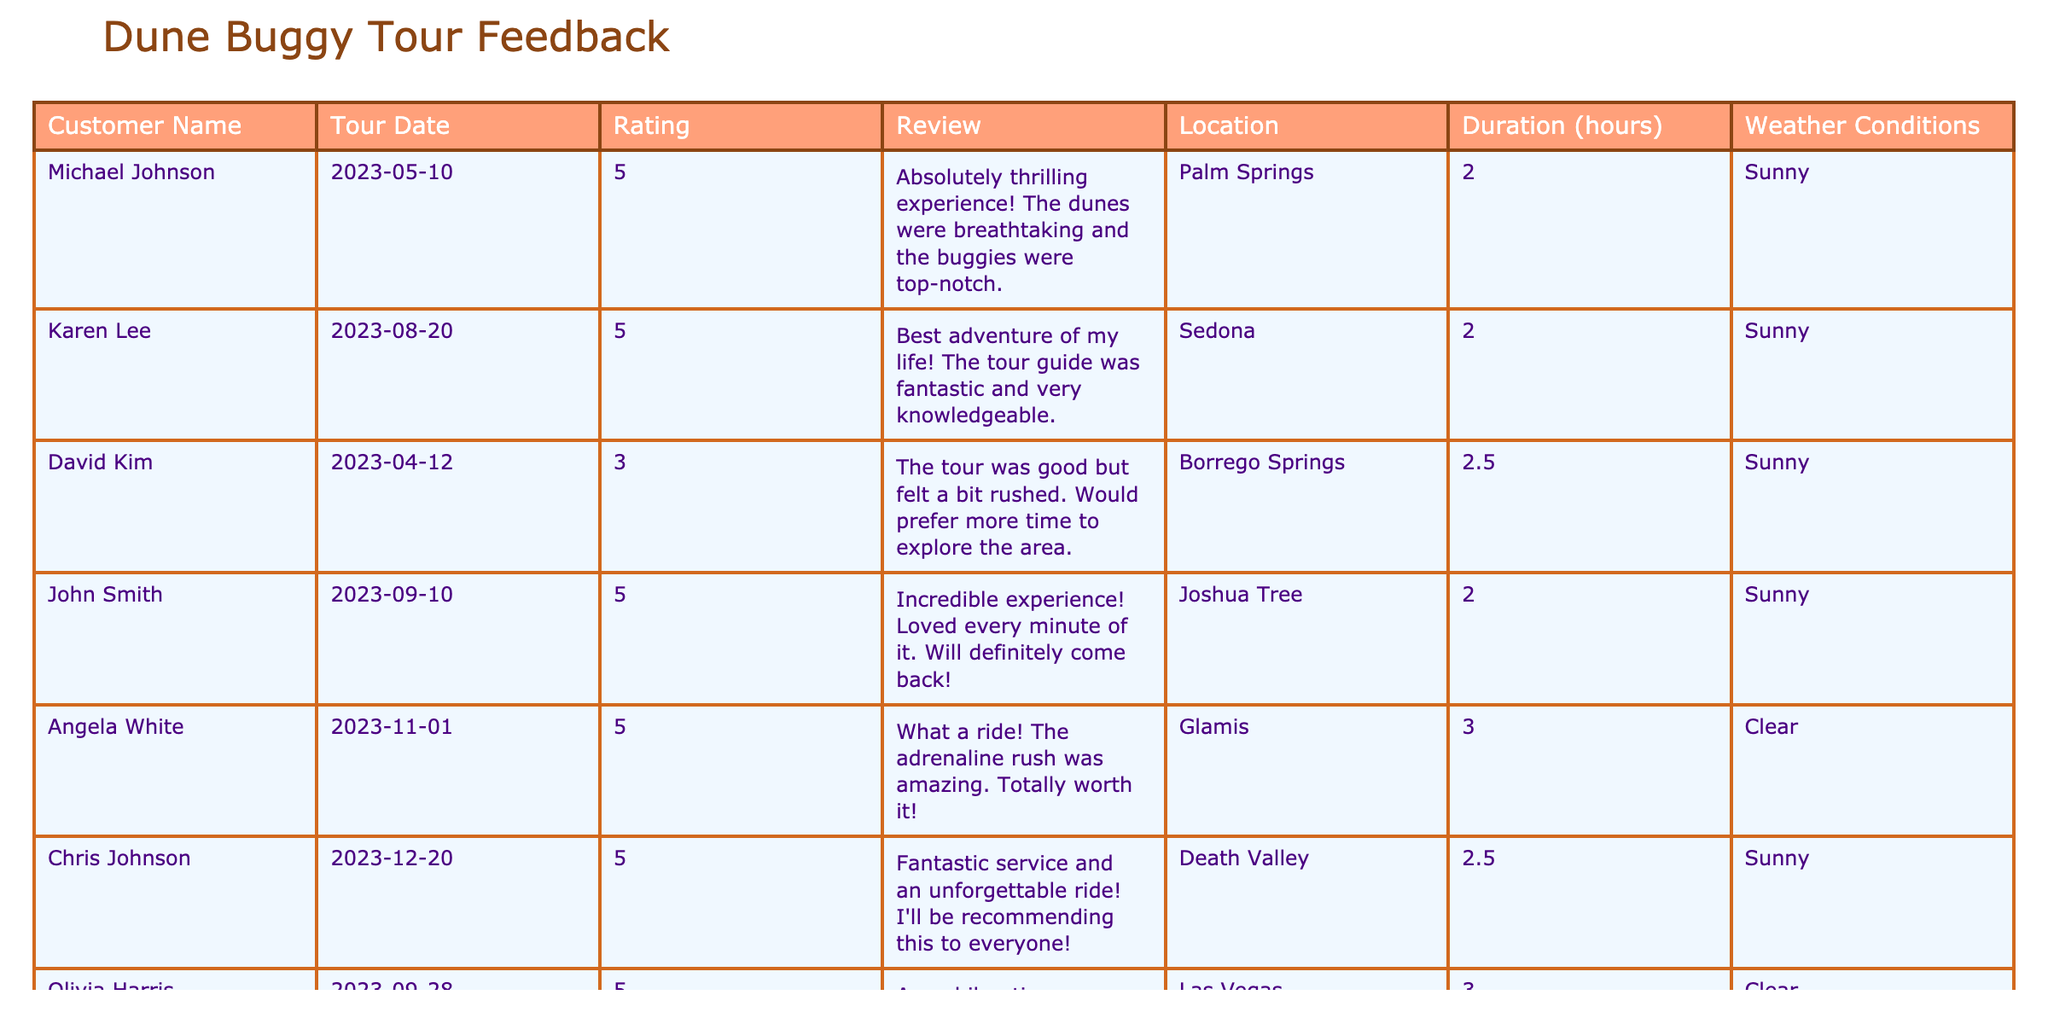What is the highest customer rating in the table? The highest rating listed in the table is 5, which appears multiple times for various customers.
Answer: 5 How many reviews mention the experience as "thrilling"? Only one review explicitly uses the word "thrilling," which was made by Michael Johnson.
Answer: 1 What is the average rating from the reviews? The ratings provided are 5, 5, 3, 5, 5, 5, 5. To find the average, we sum them (5+5+3+5+5+5+5=33) and divide by 7, which equals approximately 4.71.
Answer: 4.71 Which tour location received the most positive reviews (5-star ratings)? The locations with 5-star ratings include Palm Springs, Sedona, Joshua Tree, Glamis, Death Valley, and Las Vegas. Counting them shows there are six distinct positive reviews.
Answer: 6 Did any customers comment on the weather conditions in their reviews? No specific comments about weather conditions are mentioned in the reviews, only that the tours occurred in sunny or clear weather.
Answer: No Which customer had a review that expressed a desire for more time? David Kim expressed a desire for more time in his review, stating that he felt the tour was rushed.
Answer: David Kim How many tours took place in September? The entries for September are John Smith on the 10th and Olivia Harris on the 28th, totaling two tours in that month.
Answer: 2 Does any customer rating indicate a score lower than 4? Yes, David Kim rated the tour with a 3, which is lower than 4.
Answer: Yes What is the location with the longest tour duration listed? The longest tour duration in the table is 3 hours, which belongs to Angela White's tour in Glamis.
Answer: Glamis For customers who rated their experience a 5, how many mentioned the guide’s expertise? Karen Lee mentioned that the tour guide was fantastic and knowledgeable, making it the only specific mention among 5-star ratings.
Answer: 1 